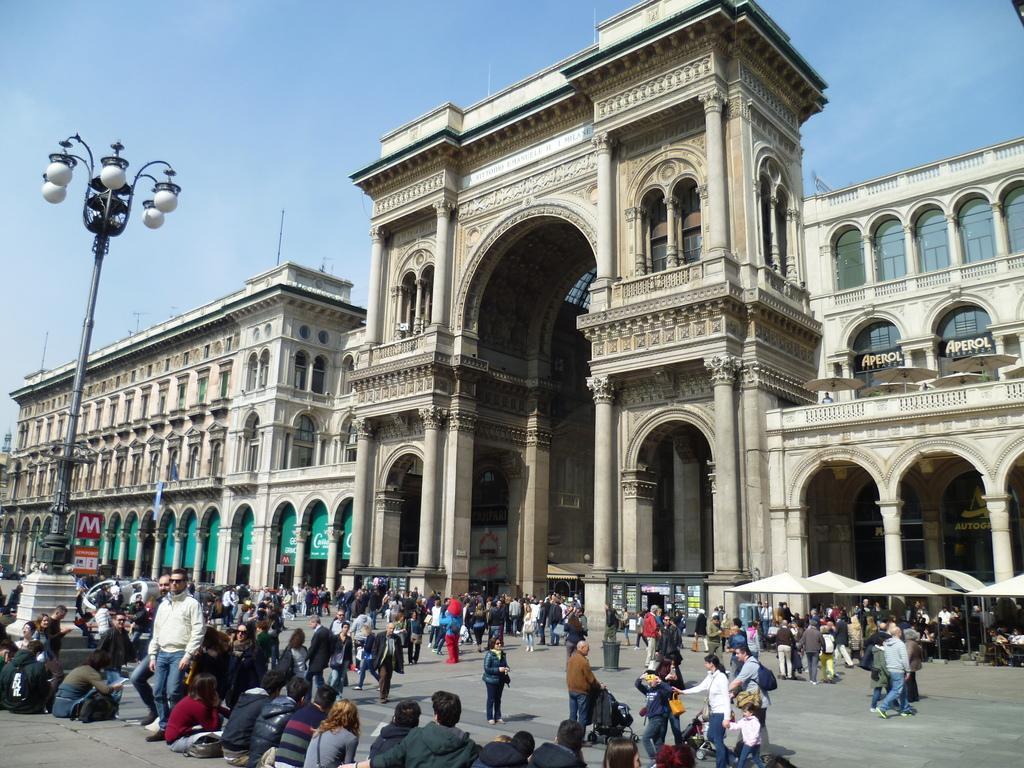How would you summarize this image in a sentence or two? In this image, we can see buildings, walls, pillars, glass windows, pole and lights. At the bottom of the image, we can see people, banners, stalls and few objects. Background we can see the sky. 